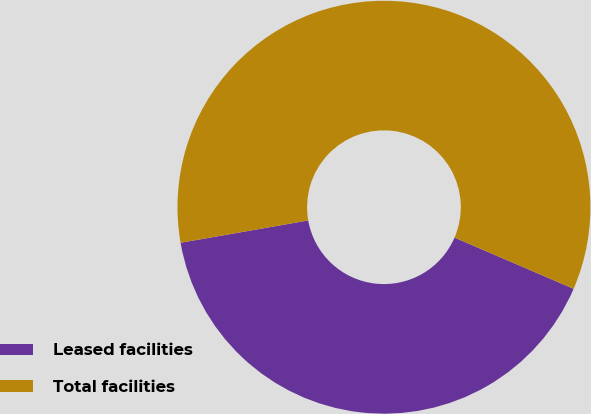<chart> <loc_0><loc_0><loc_500><loc_500><pie_chart><fcel>Leased facilities<fcel>Total facilities<nl><fcel>40.78%<fcel>59.22%<nl></chart> 